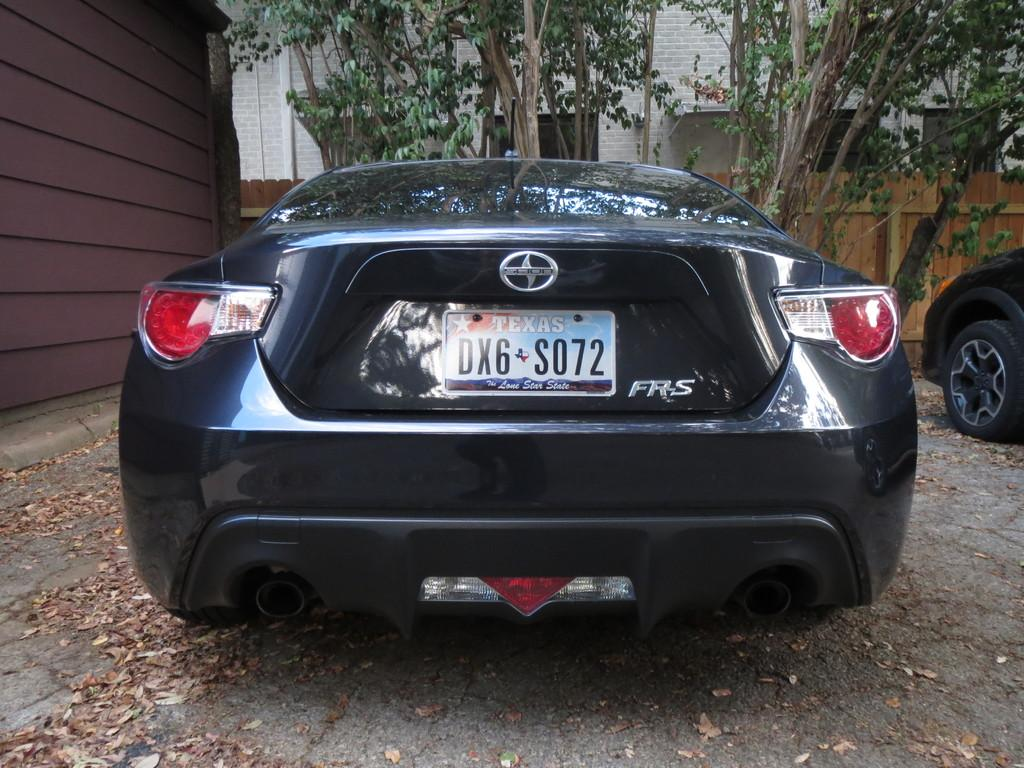What can be seen in the foreground of the picture? There are dry leaves and a car in the foreground of the picture. Are there any other vehicles visible in the picture? Yes, there is another car on the right side of the picture. What is located on the left side of the picture? There is a well on the left side of the picture. What can be seen in the background of the picture? There are trees and a building in the background of the picture. Can you tell me how many borders are visible in the image? There are no borders visible in the image; it is a photograph of a scene with various objects and structures. What type of steam is coming out of the well in the image? There is no steam coming out of the well in the image; it is a dry well. 